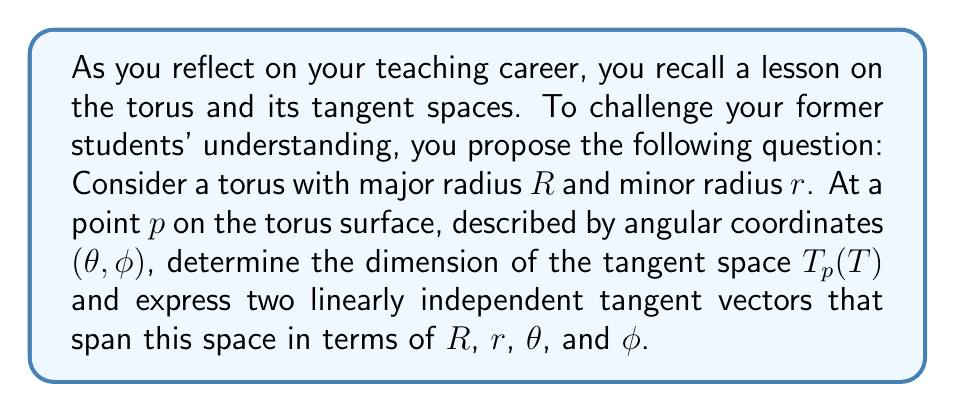What is the answer to this math problem? Let's approach this step-by-step:

1) First, recall that a torus is a 2-dimensional manifold embedded in 3-dimensional space. This means that the tangent space at any point on the torus will be 2-dimensional.

2) To find tangent vectors, we need to parameterize the torus. A standard parameterization is:

   $$x(\theta, \phi) = (R + r\cos\phi)\cos\theta$$
   $$y(\theta, \phi) = (R + r\cos\phi)\sin\theta$$
   $$z(\theta, \phi) = r\sin\phi$$

   Where $0 \leq \theta < 2\pi$ and $0 \leq \phi < 2\pi$.

3) The tangent vectors can be found by taking partial derivatives with respect to $\theta$ and $\phi$:

   $$\frac{\partial}{\partial\theta} = \left(-(R + r\cos\phi)\sin\theta, (R + r\cos\phi)\cos\theta, 0\right)$$

   $$\frac{\partial}{\partial\phi} = \left(-r\sin\phi\cos\theta, -r\sin\phi\sin\theta, r\cos\phi\right)$$

4) These vectors form a basis for the tangent space at any point $p$ on the torus. They are clearly linearly independent as they point in different directions on the surface.

5) To express these in terms of the given parameters at a specific point $p$:

   $v_1 = \frac{\partial}{\partial\theta} = \left(-(R + r\cos\phi)\sin\theta, (R + r\cos\phi)\cos\theta, 0\right)$

   $v_2 = \frac{\partial}{\partial\phi} = \left(-r\sin\phi\cos\theta, -r\sin\phi\sin\theta, r\cos\phi\right)$

These vectors $v_1$ and $v_2$ span the 2-dimensional tangent space $T_p(T)$ at the point $p$.
Answer: The dimension of the tangent space $T_p(T)$ is 2, and two linearly independent tangent vectors that span this space are:

$v_1 = \left(-(R + r\cos\phi)\sin\theta, (R + r\cos\phi)\cos\theta, 0\right)$

$v_2 = \left(-r\sin\phi\cos\theta, -r\sin\phi\sin\theta, r\cos\phi\right)$ 